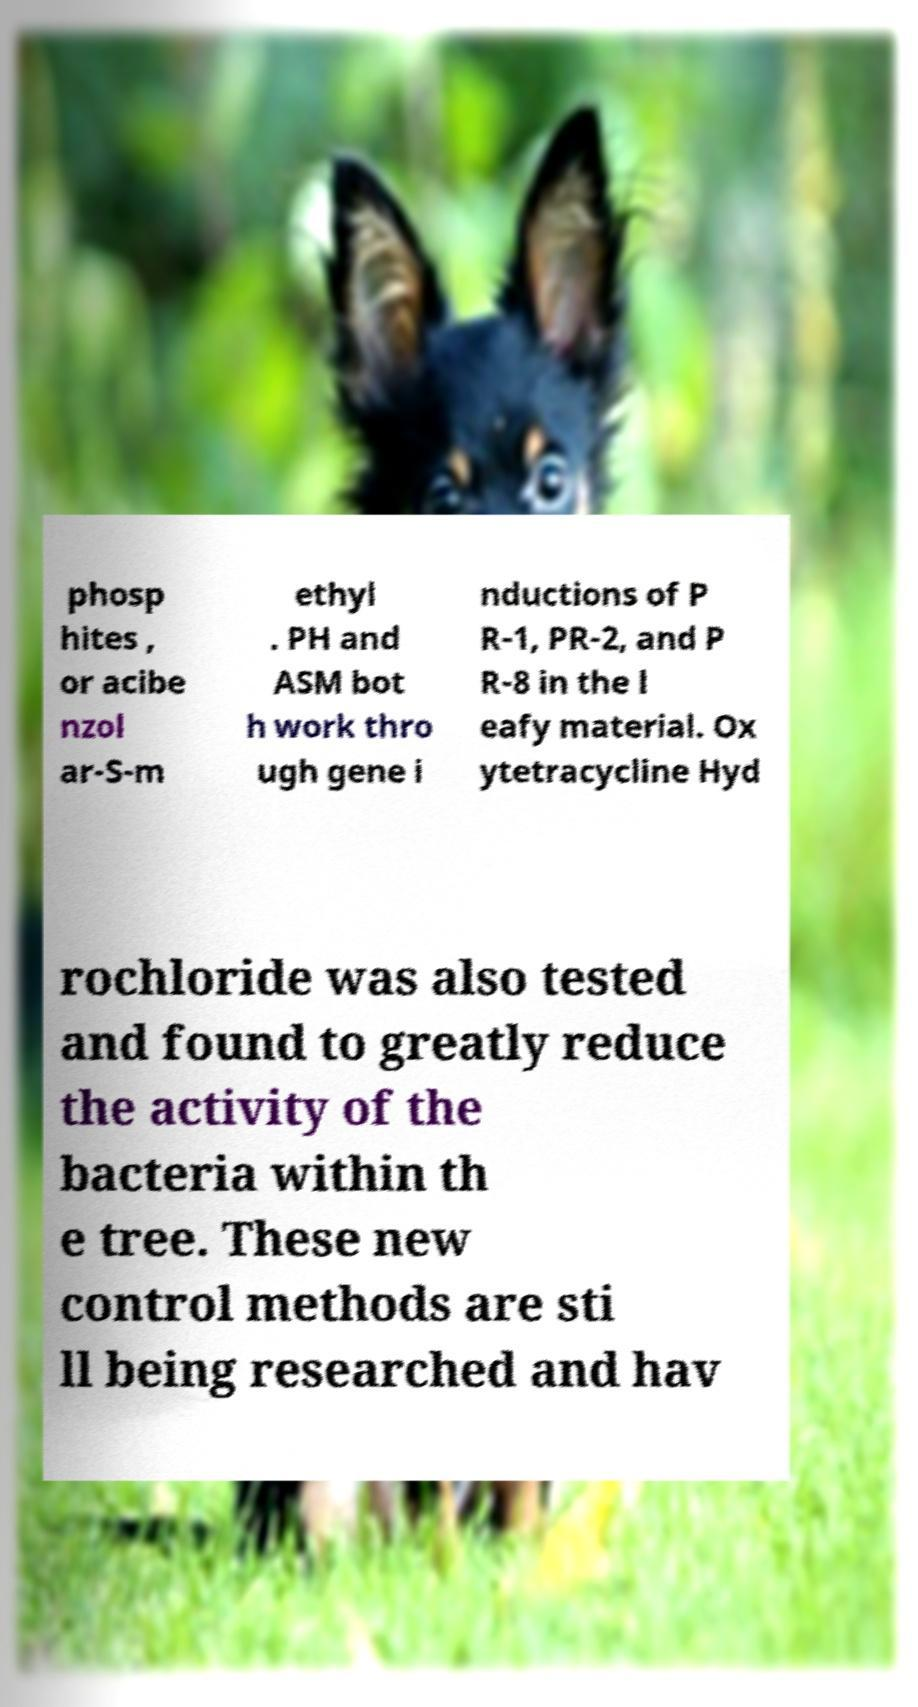Please read and relay the text visible in this image. What does it say? phosp hites , or acibe nzol ar-S-m ethyl . PH and ASM bot h work thro ugh gene i nductions of P R-1, PR-2, and P R-8 in the l eafy material. Ox ytetracycline Hyd rochloride was also tested and found to greatly reduce the activity of the bacteria within th e tree. These new control methods are sti ll being researched and hav 